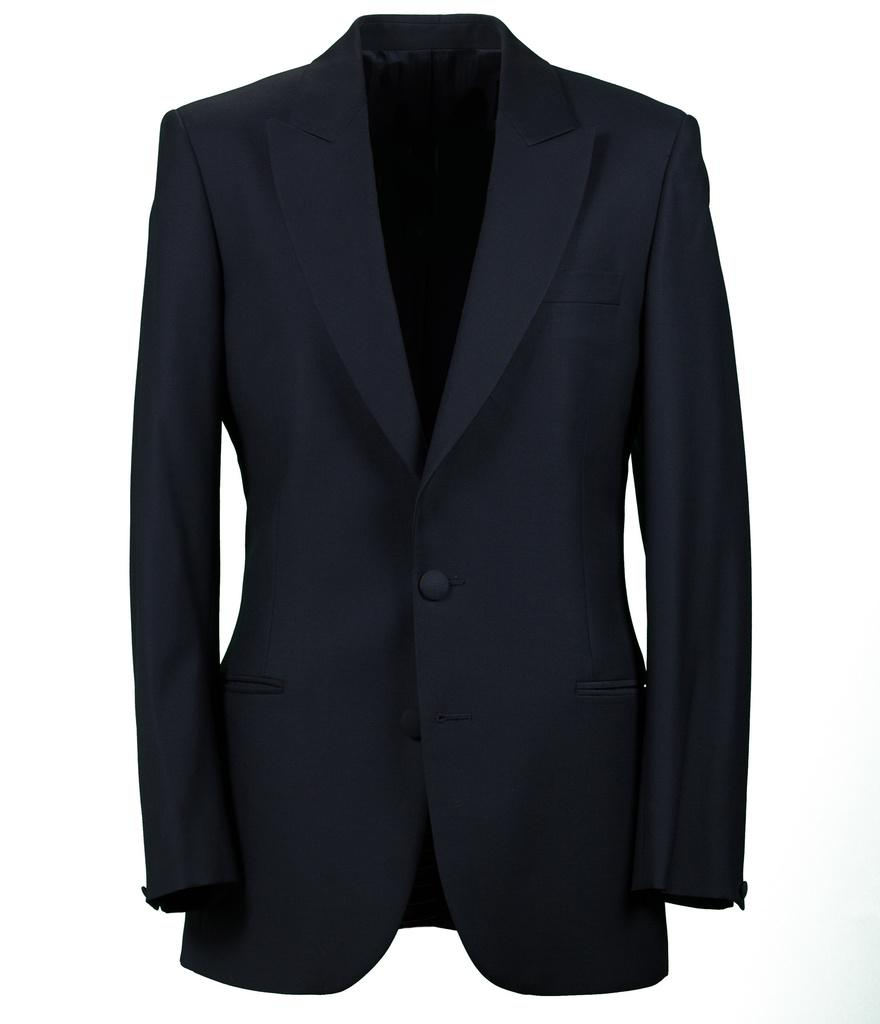What type of clothing is featured in the image? There is a slim button suit in the image. What color is the suit? The suit is black in color. What type of tooth is visible in the image? There is no tooth present in the image; it features a slim button suit. What is the reason for the protest in the image? There is no protest depicted in the image; it only shows a black slim button suit. 